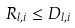<formula> <loc_0><loc_0><loc_500><loc_500>R _ { l , i } \leq D _ { l , i }</formula> 